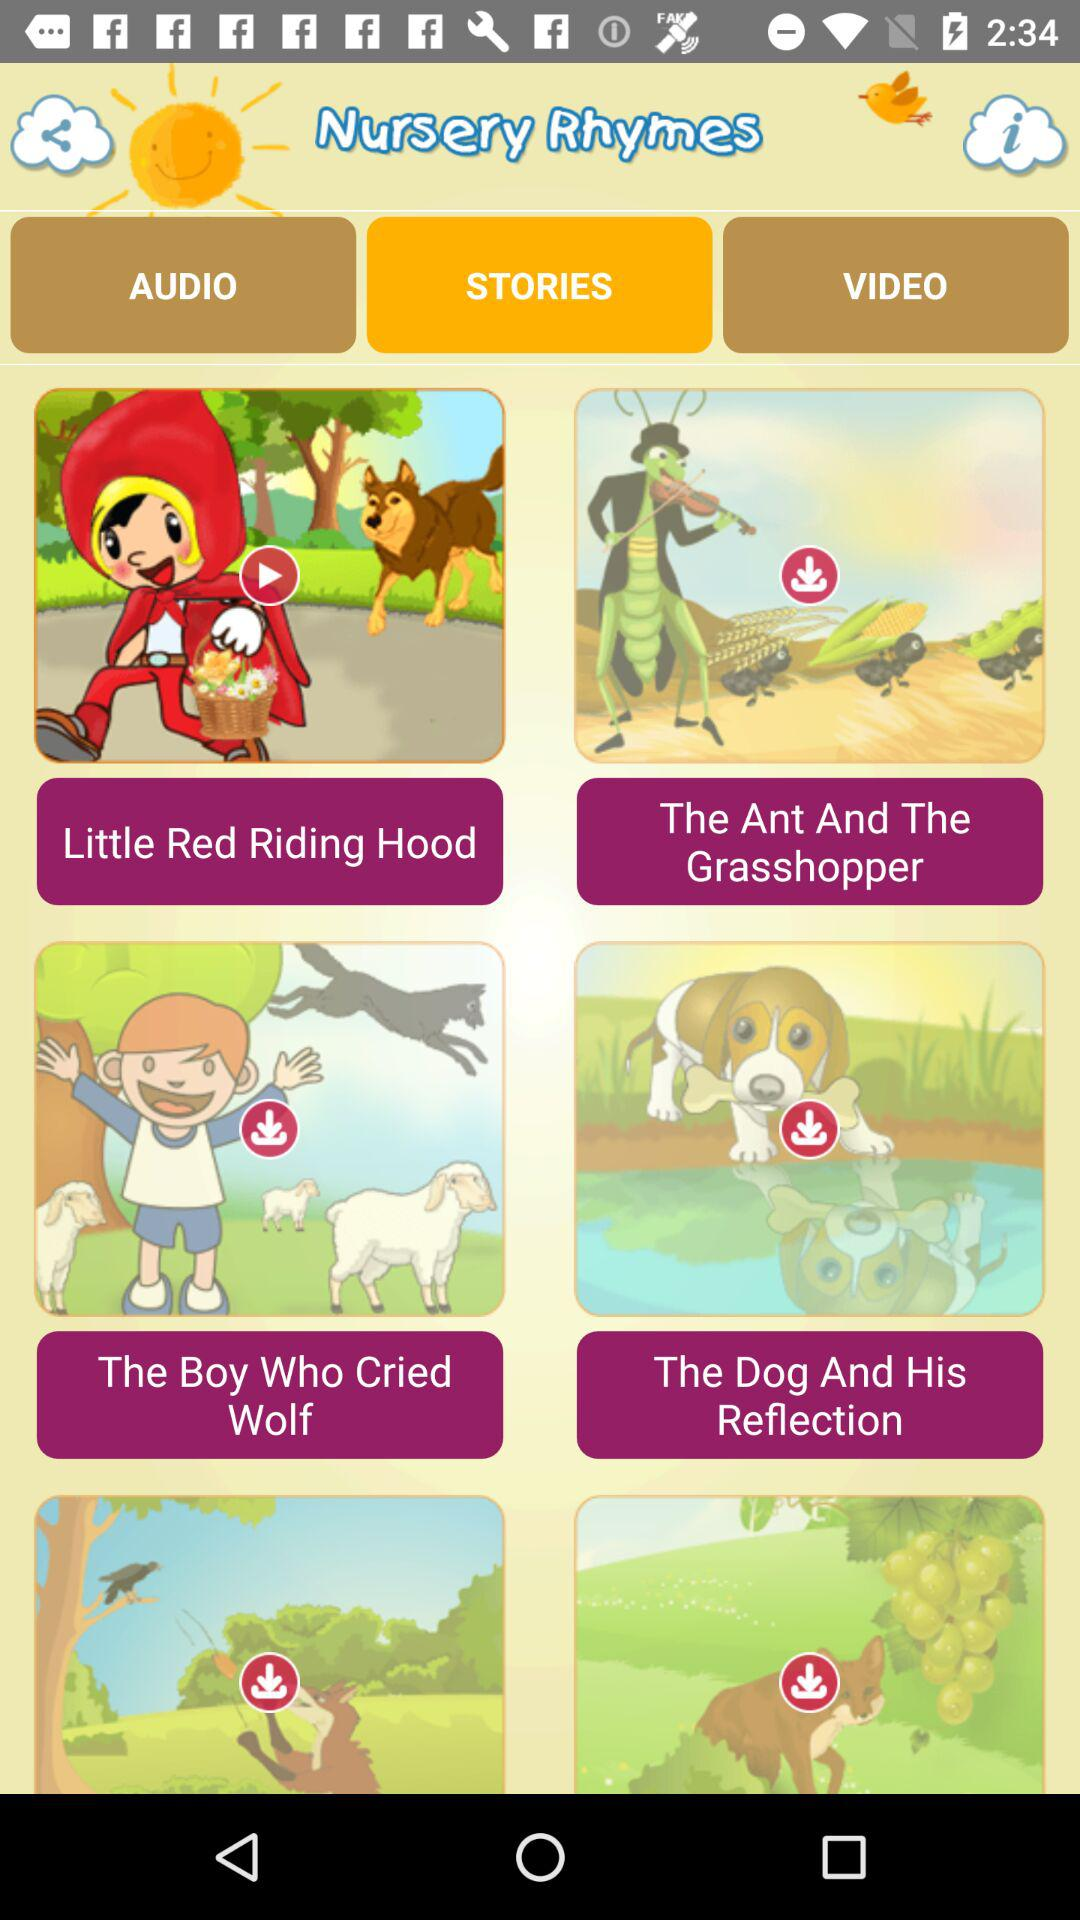Which tab has been selected? The selected tab is "STORIES". 